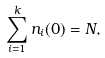<formula> <loc_0><loc_0><loc_500><loc_500>\sum _ { i = 1 } ^ { k } n _ { i } ( 0 ) = N ,</formula> 